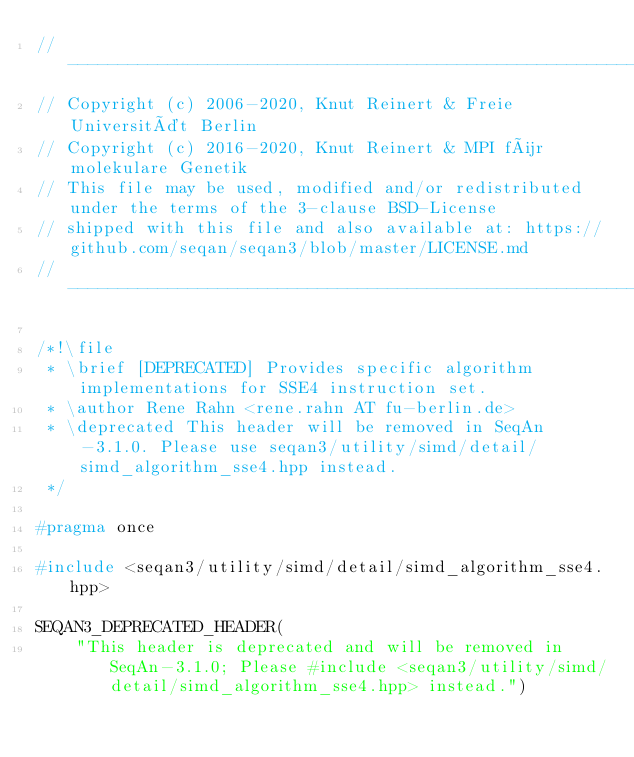<code> <loc_0><loc_0><loc_500><loc_500><_C++_>// -----------------------------------------------------------------------------------------------------
// Copyright (c) 2006-2020, Knut Reinert & Freie Universität Berlin
// Copyright (c) 2016-2020, Knut Reinert & MPI für molekulare Genetik
// This file may be used, modified and/or redistributed under the terms of the 3-clause BSD-License
// shipped with this file and also available at: https://github.com/seqan/seqan3/blob/master/LICENSE.md
// -----------------------------------------------------------------------------------------------------

/*!\file
 * \brief [DEPRECATED] Provides specific algorithm implementations for SSE4 instruction set.
 * \author Rene Rahn <rene.rahn AT fu-berlin.de>
 * \deprecated This header will be removed in SeqAn-3.1.0. Please use seqan3/utility/simd/detail/simd_algorithm_sse4.hpp instead.
 */

#pragma once

#include <seqan3/utility/simd/detail/simd_algorithm_sse4.hpp>

SEQAN3_DEPRECATED_HEADER(
    "This header is deprecated and will be removed in SeqAn-3.1.0; Please #include <seqan3/utility/simd/detail/simd_algorithm_sse4.hpp> instead.")
</code> 